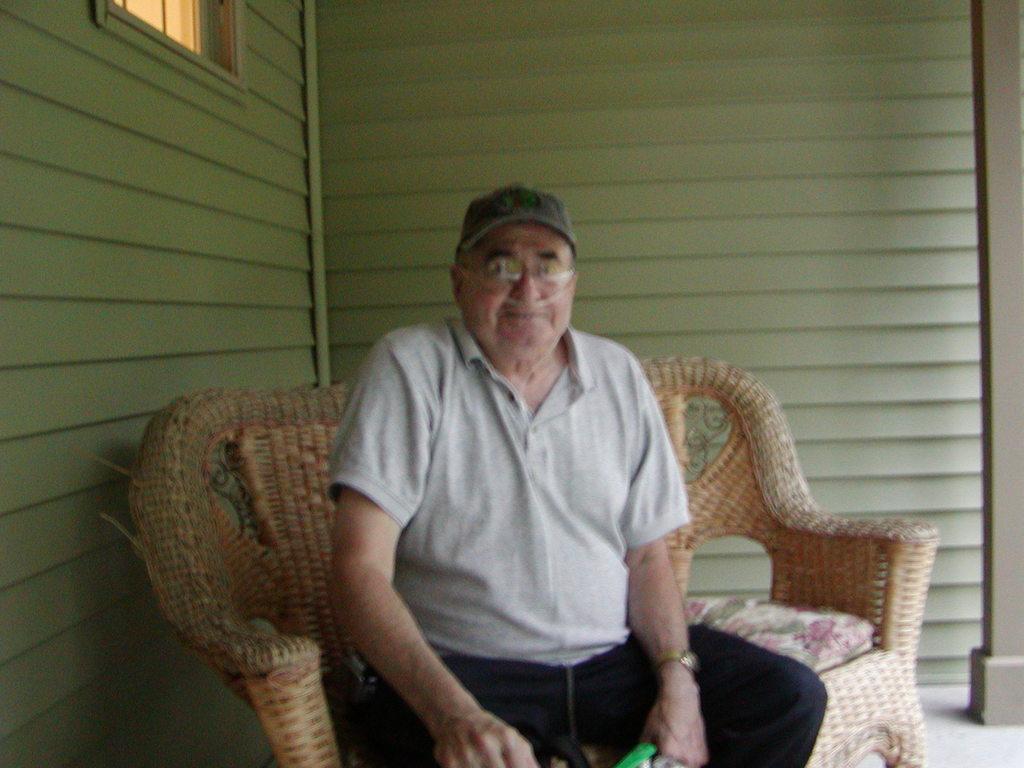Can you describe this image briefly? In this image in front there is a person sitting on the couch. Behind him there is a wall. There is a window. At the bottom of the image there is a floor. 